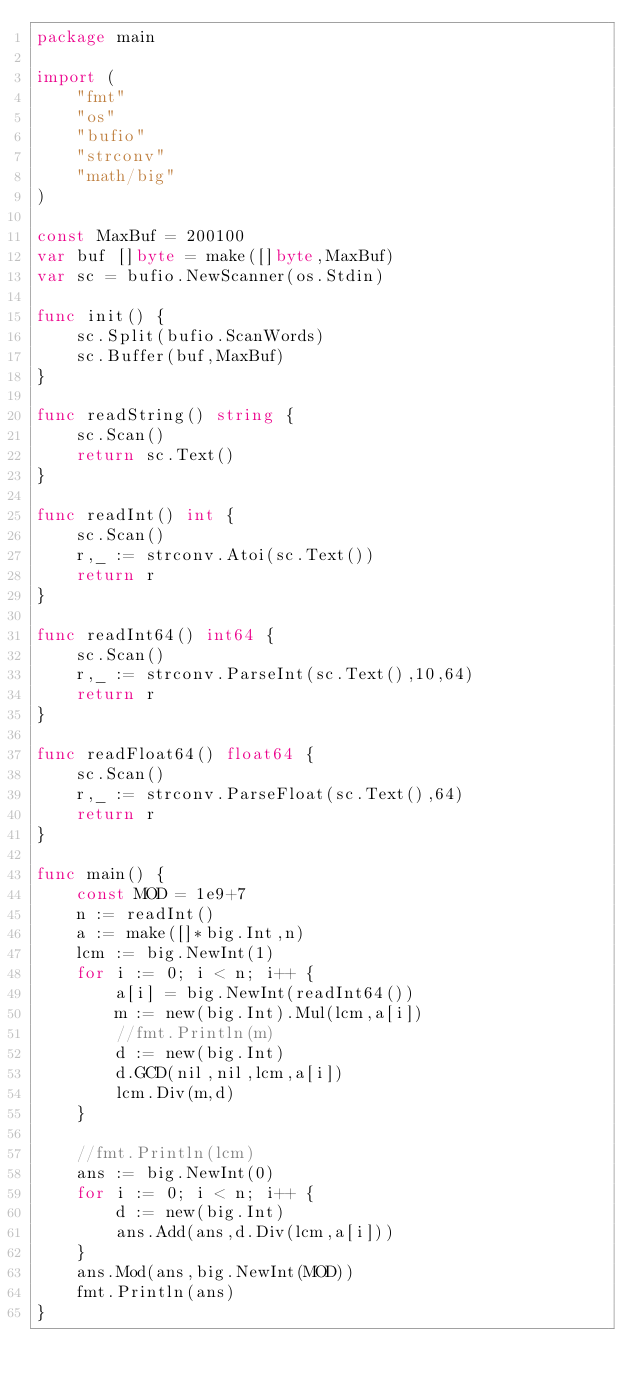Convert code to text. <code><loc_0><loc_0><loc_500><loc_500><_Go_>package main

import (
	"fmt"
	"os"
	"bufio"
	"strconv"
	"math/big"
)

const MaxBuf = 200100
var buf []byte = make([]byte,MaxBuf)
var sc = bufio.NewScanner(os.Stdin)

func init() {
	sc.Split(bufio.ScanWords)
	sc.Buffer(buf,MaxBuf)
}

func readString() string {
	sc.Scan()
	return sc.Text()
}

func readInt() int {
	sc.Scan()
	r,_ := strconv.Atoi(sc.Text())
	return r
}

func readInt64() int64 {
	sc.Scan()
	r,_ := strconv.ParseInt(sc.Text(),10,64)
	return r
}

func readFloat64() float64 {
	sc.Scan()
	r,_ := strconv.ParseFloat(sc.Text(),64)
	return r
}

func main() {
	const MOD = 1e9+7
	n := readInt()
	a := make([]*big.Int,n)
	lcm := big.NewInt(1)
	for i := 0; i < n; i++ {
		a[i] = big.NewInt(readInt64())
		m := new(big.Int).Mul(lcm,a[i])
		//fmt.Println(m)
		d := new(big.Int)
		d.GCD(nil,nil,lcm,a[i])
		lcm.Div(m,d)
	}

    //fmt.Println(lcm)
	ans := big.NewInt(0)
	for i := 0; i < n; i++ {
	    d := new(big.Int)
		ans.Add(ans,d.Div(lcm,a[i]))
	}
	ans.Mod(ans,big.NewInt(MOD))
	fmt.Println(ans)
}</code> 